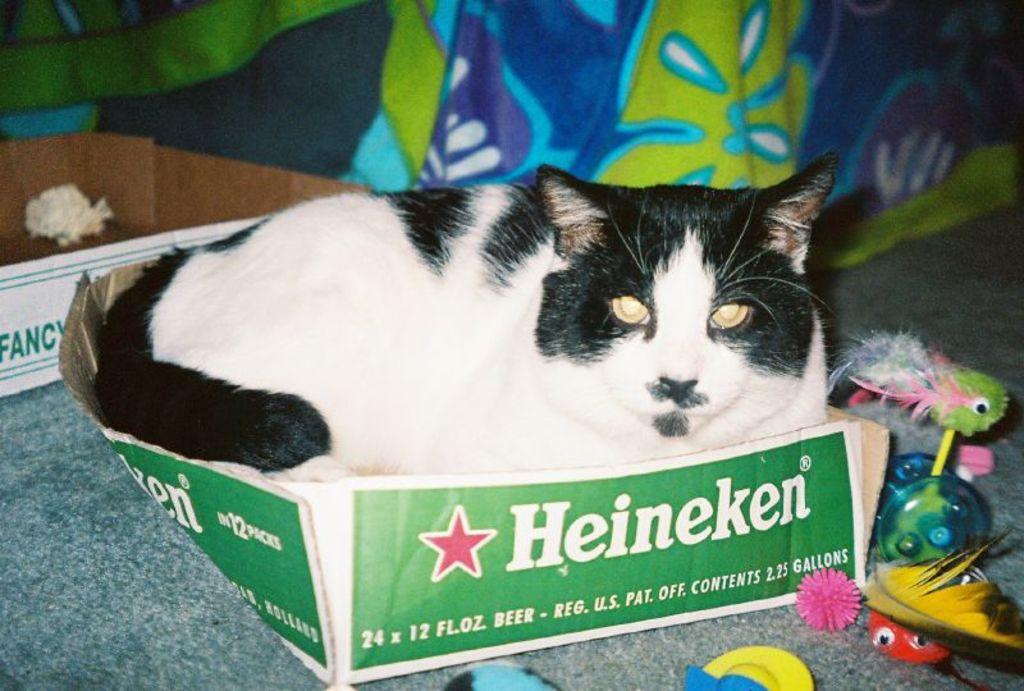What sort of box is the cat sitting in?
Keep it short and to the point. Heineken. What kind of box is the cat sitting on?
Give a very brief answer. Heineken. 